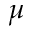<formula> <loc_0><loc_0><loc_500><loc_500>\mu</formula> 